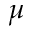<formula> <loc_0><loc_0><loc_500><loc_500>\mu</formula> 